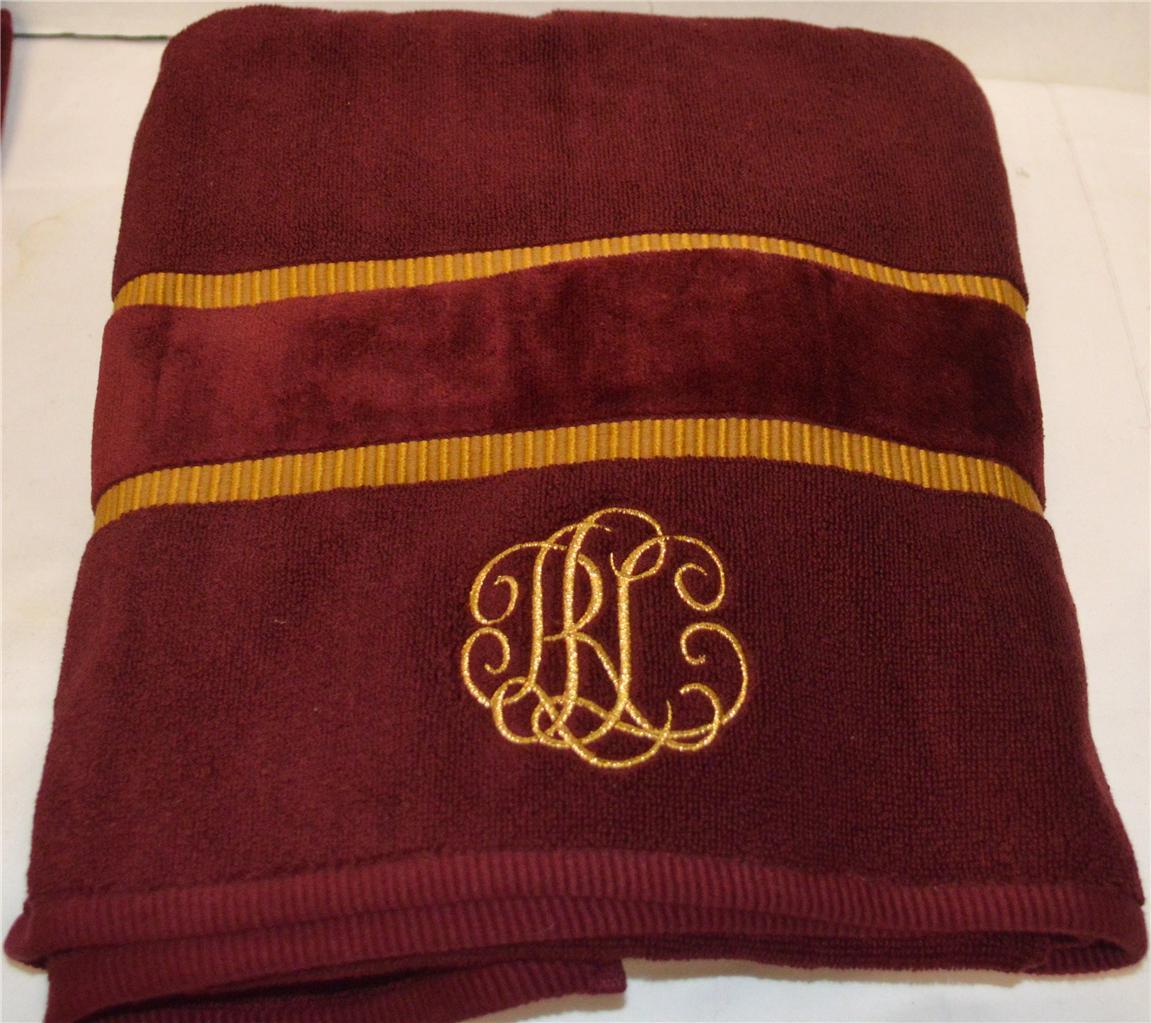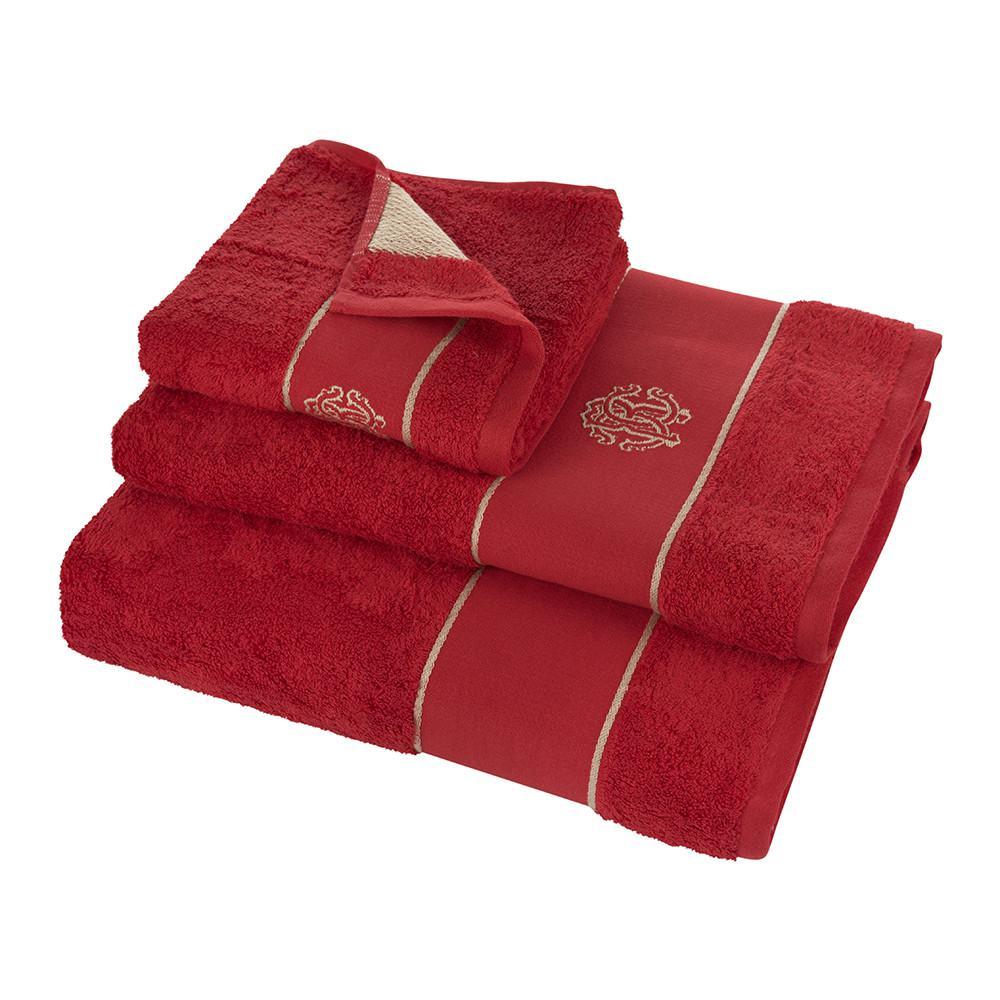The first image is the image on the left, the second image is the image on the right. Considering the images on both sides, is "IN at least one image there is a tower of three red towels." valid? Answer yes or no. Yes. The first image is the image on the left, the second image is the image on the right. For the images shown, is this caption "Seven or fewer towels are visible." true? Answer yes or no. Yes. 